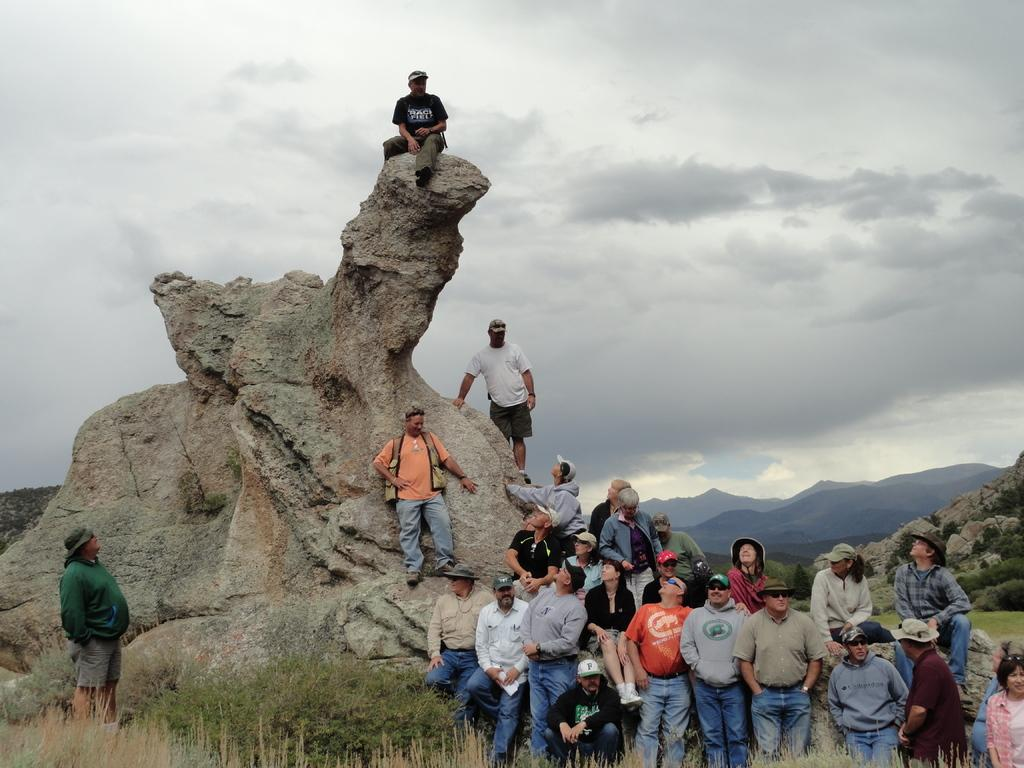Who or what can be seen in the image? There are people in the image. What type of natural landscape is present in the image? There are hills, rocks, grass, and plants visible in the image. What is the ground like in the image? The ground is visible in the image. What can be seen in the sky in the image? The sky is visible in the image, and there are clouds present. What type of organization is depicted in the image? There is no organization present in the image; it features people in a natural landscape with hills, rocks, grass, plants, and clouds. What industry is represented by the people in the image? There is no specific industry represented by the people in the image; they are simply present in a natural landscape. 